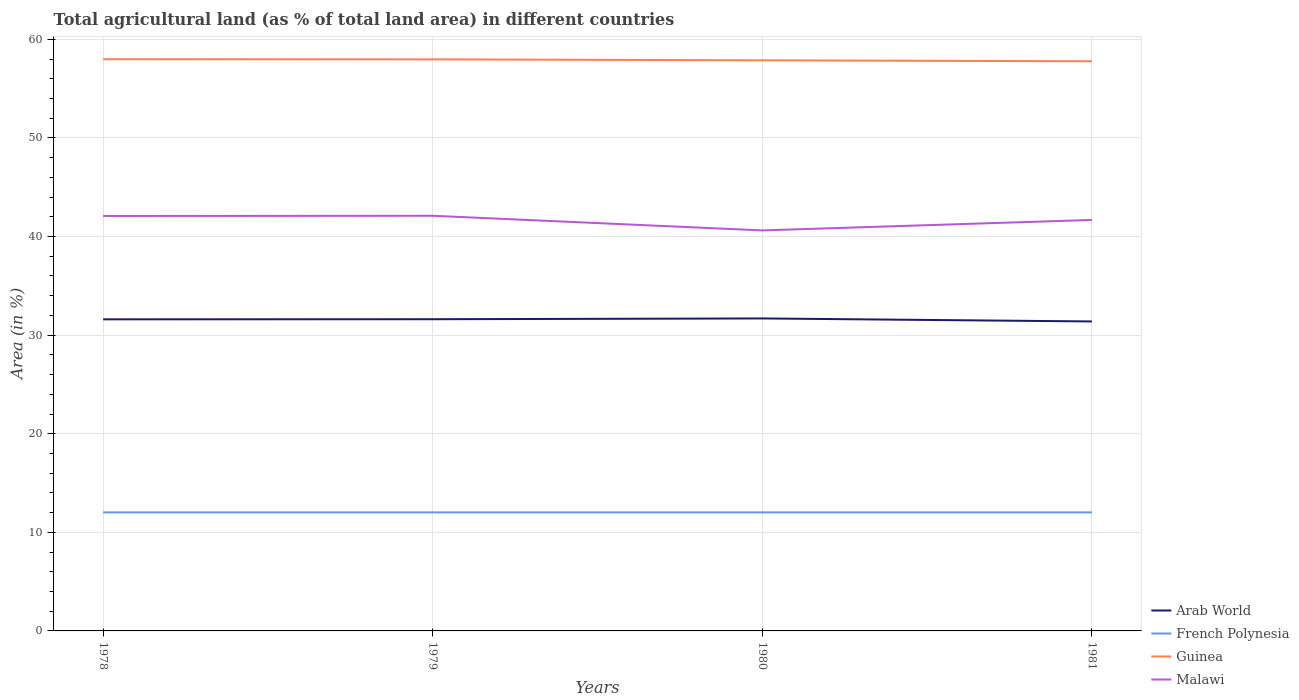How many different coloured lines are there?
Your answer should be compact. 4. Does the line corresponding to Arab World intersect with the line corresponding to French Polynesia?
Provide a short and direct response. No. Across all years, what is the maximum percentage of agricultural land in French Polynesia?
Ensure brevity in your answer.  12.02. What is the total percentage of agricultural land in Guinea in the graph?
Make the answer very short. 0.2. What is the difference between the highest and the second highest percentage of agricultural land in Arab World?
Provide a succinct answer. 0.31. What is the difference between the highest and the lowest percentage of agricultural land in French Polynesia?
Your response must be concise. 0. How many lines are there?
Make the answer very short. 4. How many years are there in the graph?
Your answer should be very brief. 4. Does the graph contain any zero values?
Give a very brief answer. No. Does the graph contain grids?
Offer a very short reply. Yes. How many legend labels are there?
Give a very brief answer. 4. What is the title of the graph?
Offer a very short reply. Total agricultural land (as % of total land area) in different countries. What is the label or title of the X-axis?
Give a very brief answer. Years. What is the label or title of the Y-axis?
Ensure brevity in your answer.  Area (in %). What is the Area (in %) in Arab World in 1978?
Offer a terse response. 31.6. What is the Area (in %) of French Polynesia in 1978?
Offer a terse response. 12.02. What is the Area (in %) of Guinea in 1978?
Offer a terse response. 57.98. What is the Area (in %) of Malawi in 1978?
Provide a succinct answer. 42.09. What is the Area (in %) in Arab World in 1979?
Give a very brief answer. 31.62. What is the Area (in %) of French Polynesia in 1979?
Provide a succinct answer. 12.02. What is the Area (in %) in Guinea in 1979?
Keep it short and to the point. 57.97. What is the Area (in %) in Malawi in 1979?
Keep it short and to the point. 42.11. What is the Area (in %) of Arab World in 1980?
Ensure brevity in your answer.  31.69. What is the Area (in %) of French Polynesia in 1980?
Offer a terse response. 12.02. What is the Area (in %) of Guinea in 1980?
Your answer should be very brief. 57.87. What is the Area (in %) in Malawi in 1980?
Your answer should be compact. 40.62. What is the Area (in %) in Arab World in 1981?
Make the answer very short. 31.39. What is the Area (in %) of French Polynesia in 1981?
Your answer should be compact. 12.02. What is the Area (in %) in Guinea in 1981?
Your answer should be compact. 57.78. What is the Area (in %) in Malawi in 1981?
Your answer should be very brief. 41.68. Across all years, what is the maximum Area (in %) of Arab World?
Your answer should be compact. 31.69. Across all years, what is the maximum Area (in %) of French Polynesia?
Your answer should be compact. 12.02. Across all years, what is the maximum Area (in %) of Guinea?
Provide a short and direct response. 57.98. Across all years, what is the maximum Area (in %) in Malawi?
Your answer should be very brief. 42.11. Across all years, what is the minimum Area (in %) in Arab World?
Offer a terse response. 31.39. Across all years, what is the minimum Area (in %) in French Polynesia?
Give a very brief answer. 12.02. Across all years, what is the minimum Area (in %) in Guinea?
Keep it short and to the point. 57.78. Across all years, what is the minimum Area (in %) in Malawi?
Your answer should be very brief. 40.62. What is the total Area (in %) in Arab World in the graph?
Offer a very short reply. 126.3. What is the total Area (in %) in French Polynesia in the graph?
Provide a succinct answer. 48.09. What is the total Area (in %) in Guinea in the graph?
Your answer should be very brief. 231.61. What is the total Area (in %) of Malawi in the graph?
Provide a succinct answer. 166.5. What is the difference between the Area (in %) of Arab World in 1978 and that in 1979?
Your answer should be compact. -0.01. What is the difference between the Area (in %) in Guinea in 1978 and that in 1979?
Give a very brief answer. 0.01. What is the difference between the Area (in %) of Malawi in 1978 and that in 1979?
Give a very brief answer. -0.02. What is the difference between the Area (in %) of Arab World in 1978 and that in 1980?
Ensure brevity in your answer.  -0.09. What is the difference between the Area (in %) in French Polynesia in 1978 and that in 1980?
Give a very brief answer. 0. What is the difference between the Area (in %) in Guinea in 1978 and that in 1980?
Give a very brief answer. 0.11. What is the difference between the Area (in %) in Malawi in 1978 and that in 1980?
Ensure brevity in your answer.  1.46. What is the difference between the Area (in %) in Arab World in 1978 and that in 1981?
Your response must be concise. 0.22. What is the difference between the Area (in %) in Guinea in 1978 and that in 1981?
Provide a succinct answer. 0.21. What is the difference between the Area (in %) of Malawi in 1978 and that in 1981?
Make the answer very short. 0.4. What is the difference between the Area (in %) of Arab World in 1979 and that in 1980?
Your answer should be compact. -0.08. What is the difference between the Area (in %) in French Polynesia in 1979 and that in 1980?
Provide a short and direct response. 0. What is the difference between the Area (in %) of Guinea in 1979 and that in 1980?
Ensure brevity in your answer.  0.1. What is the difference between the Area (in %) of Malawi in 1979 and that in 1980?
Your response must be concise. 1.48. What is the difference between the Area (in %) in Arab World in 1979 and that in 1981?
Your answer should be very brief. 0.23. What is the difference between the Area (in %) in French Polynesia in 1979 and that in 1981?
Give a very brief answer. 0. What is the difference between the Area (in %) in Guinea in 1979 and that in 1981?
Provide a short and direct response. 0.2. What is the difference between the Area (in %) in Malawi in 1979 and that in 1981?
Offer a very short reply. 0.42. What is the difference between the Area (in %) in Arab World in 1980 and that in 1981?
Your response must be concise. 0.31. What is the difference between the Area (in %) of Guinea in 1980 and that in 1981?
Keep it short and to the point. 0.1. What is the difference between the Area (in %) of Malawi in 1980 and that in 1981?
Offer a terse response. -1.06. What is the difference between the Area (in %) of Arab World in 1978 and the Area (in %) of French Polynesia in 1979?
Your answer should be very brief. 19.58. What is the difference between the Area (in %) in Arab World in 1978 and the Area (in %) in Guinea in 1979?
Your response must be concise. -26.37. What is the difference between the Area (in %) of Arab World in 1978 and the Area (in %) of Malawi in 1979?
Provide a succinct answer. -10.5. What is the difference between the Area (in %) of French Polynesia in 1978 and the Area (in %) of Guinea in 1979?
Your response must be concise. -45.95. What is the difference between the Area (in %) in French Polynesia in 1978 and the Area (in %) in Malawi in 1979?
Keep it short and to the point. -30.09. What is the difference between the Area (in %) in Guinea in 1978 and the Area (in %) in Malawi in 1979?
Offer a very short reply. 15.88. What is the difference between the Area (in %) in Arab World in 1978 and the Area (in %) in French Polynesia in 1980?
Your answer should be very brief. 19.58. What is the difference between the Area (in %) of Arab World in 1978 and the Area (in %) of Guinea in 1980?
Your answer should be compact. -26.27. What is the difference between the Area (in %) of Arab World in 1978 and the Area (in %) of Malawi in 1980?
Offer a terse response. -9.02. What is the difference between the Area (in %) in French Polynesia in 1978 and the Area (in %) in Guinea in 1980?
Your response must be concise. -45.85. What is the difference between the Area (in %) in French Polynesia in 1978 and the Area (in %) in Malawi in 1980?
Keep it short and to the point. -28.6. What is the difference between the Area (in %) of Guinea in 1978 and the Area (in %) of Malawi in 1980?
Give a very brief answer. 17.36. What is the difference between the Area (in %) in Arab World in 1978 and the Area (in %) in French Polynesia in 1981?
Provide a short and direct response. 19.58. What is the difference between the Area (in %) in Arab World in 1978 and the Area (in %) in Guinea in 1981?
Provide a succinct answer. -26.17. What is the difference between the Area (in %) of Arab World in 1978 and the Area (in %) of Malawi in 1981?
Provide a short and direct response. -10.08. What is the difference between the Area (in %) in French Polynesia in 1978 and the Area (in %) in Guinea in 1981?
Provide a short and direct response. -45.76. What is the difference between the Area (in %) in French Polynesia in 1978 and the Area (in %) in Malawi in 1981?
Your answer should be compact. -29.66. What is the difference between the Area (in %) in Guinea in 1978 and the Area (in %) in Malawi in 1981?
Your response must be concise. 16.3. What is the difference between the Area (in %) of Arab World in 1979 and the Area (in %) of French Polynesia in 1980?
Your answer should be compact. 19.59. What is the difference between the Area (in %) of Arab World in 1979 and the Area (in %) of Guinea in 1980?
Offer a terse response. -26.26. What is the difference between the Area (in %) of Arab World in 1979 and the Area (in %) of Malawi in 1980?
Make the answer very short. -9.01. What is the difference between the Area (in %) in French Polynesia in 1979 and the Area (in %) in Guinea in 1980?
Give a very brief answer. -45.85. What is the difference between the Area (in %) in French Polynesia in 1979 and the Area (in %) in Malawi in 1980?
Offer a terse response. -28.6. What is the difference between the Area (in %) of Guinea in 1979 and the Area (in %) of Malawi in 1980?
Give a very brief answer. 17.35. What is the difference between the Area (in %) in Arab World in 1979 and the Area (in %) in French Polynesia in 1981?
Your response must be concise. 19.59. What is the difference between the Area (in %) of Arab World in 1979 and the Area (in %) of Guinea in 1981?
Ensure brevity in your answer.  -26.16. What is the difference between the Area (in %) in Arab World in 1979 and the Area (in %) in Malawi in 1981?
Keep it short and to the point. -10.07. What is the difference between the Area (in %) of French Polynesia in 1979 and the Area (in %) of Guinea in 1981?
Keep it short and to the point. -45.76. What is the difference between the Area (in %) in French Polynesia in 1979 and the Area (in %) in Malawi in 1981?
Your response must be concise. -29.66. What is the difference between the Area (in %) in Guinea in 1979 and the Area (in %) in Malawi in 1981?
Provide a succinct answer. 16.29. What is the difference between the Area (in %) in Arab World in 1980 and the Area (in %) in French Polynesia in 1981?
Your response must be concise. 19.67. What is the difference between the Area (in %) of Arab World in 1980 and the Area (in %) of Guinea in 1981?
Your answer should be compact. -26.08. What is the difference between the Area (in %) of Arab World in 1980 and the Area (in %) of Malawi in 1981?
Keep it short and to the point. -9.99. What is the difference between the Area (in %) in French Polynesia in 1980 and the Area (in %) in Guinea in 1981?
Offer a very short reply. -45.76. What is the difference between the Area (in %) of French Polynesia in 1980 and the Area (in %) of Malawi in 1981?
Your response must be concise. -29.66. What is the difference between the Area (in %) of Guinea in 1980 and the Area (in %) of Malawi in 1981?
Offer a very short reply. 16.19. What is the average Area (in %) of Arab World per year?
Ensure brevity in your answer.  31.58. What is the average Area (in %) of French Polynesia per year?
Keep it short and to the point. 12.02. What is the average Area (in %) in Guinea per year?
Your answer should be compact. 57.9. What is the average Area (in %) in Malawi per year?
Provide a short and direct response. 41.63. In the year 1978, what is the difference between the Area (in %) of Arab World and Area (in %) of French Polynesia?
Your answer should be compact. 19.58. In the year 1978, what is the difference between the Area (in %) of Arab World and Area (in %) of Guinea?
Provide a short and direct response. -26.38. In the year 1978, what is the difference between the Area (in %) of Arab World and Area (in %) of Malawi?
Provide a short and direct response. -10.48. In the year 1978, what is the difference between the Area (in %) in French Polynesia and Area (in %) in Guinea?
Ensure brevity in your answer.  -45.96. In the year 1978, what is the difference between the Area (in %) of French Polynesia and Area (in %) of Malawi?
Provide a short and direct response. -30.07. In the year 1978, what is the difference between the Area (in %) of Guinea and Area (in %) of Malawi?
Offer a very short reply. 15.9. In the year 1979, what is the difference between the Area (in %) of Arab World and Area (in %) of French Polynesia?
Keep it short and to the point. 19.59. In the year 1979, what is the difference between the Area (in %) in Arab World and Area (in %) in Guinea?
Your answer should be very brief. -26.36. In the year 1979, what is the difference between the Area (in %) of Arab World and Area (in %) of Malawi?
Your answer should be compact. -10.49. In the year 1979, what is the difference between the Area (in %) in French Polynesia and Area (in %) in Guinea?
Make the answer very short. -45.95. In the year 1979, what is the difference between the Area (in %) of French Polynesia and Area (in %) of Malawi?
Provide a succinct answer. -30.09. In the year 1979, what is the difference between the Area (in %) in Guinea and Area (in %) in Malawi?
Offer a terse response. 15.86. In the year 1980, what is the difference between the Area (in %) in Arab World and Area (in %) in French Polynesia?
Offer a very short reply. 19.67. In the year 1980, what is the difference between the Area (in %) in Arab World and Area (in %) in Guinea?
Ensure brevity in your answer.  -26.18. In the year 1980, what is the difference between the Area (in %) in Arab World and Area (in %) in Malawi?
Your response must be concise. -8.93. In the year 1980, what is the difference between the Area (in %) in French Polynesia and Area (in %) in Guinea?
Give a very brief answer. -45.85. In the year 1980, what is the difference between the Area (in %) of French Polynesia and Area (in %) of Malawi?
Your answer should be compact. -28.6. In the year 1980, what is the difference between the Area (in %) in Guinea and Area (in %) in Malawi?
Your answer should be very brief. 17.25. In the year 1981, what is the difference between the Area (in %) of Arab World and Area (in %) of French Polynesia?
Your response must be concise. 19.37. In the year 1981, what is the difference between the Area (in %) in Arab World and Area (in %) in Guinea?
Your answer should be very brief. -26.39. In the year 1981, what is the difference between the Area (in %) in Arab World and Area (in %) in Malawi?
Your answer should be compact. -10.3. In the year 1981, what is the difference between the Area (in %) of French Polynesia and Area (in %) of Guinea?
Your answer should be compact. -45.76. In the year 1981, what is the difference between the Area (in %) in French Polynesia and Area (in %) in Malawi?
Make the answer very short. -29.66. In the year 1981, what is the difference between the Area (in %) in Guinea and Area (in %) in Malawi?
Your answer should be very brief. 16.09. What is the ratio of the Area (in %) of Guinea in 1978 to that in 1979?
Give a very brief answer. 1. What is the ratio of the Area (in %) of Malawi in 1978 to that in 1979?
Make the answer very short. 1. What is the ratio of the Area (in %) in Arab World in 1978 to that in 1980?
Offer a very short reply. 1. What is the ratio of the Area (in %) of Guinea in 1978 to that in 1980?
Provide a short and direct response. 1. What is the ratio of the Area (in %) of Malawi in 1978 to that in 1980?
Your response must be concise. 1.04. What is the ratio of the Area (in %) in Arab World in 1978 to that in 1981?
Make the answer very short. 1.01. What is the ratio of the Area (in %) of French Polynesia in 1978 to that in 1981?
Your response must be concise. 1. What is the ratio of the Area (in %) in Guinea in 1978 to that in 1981?
Keep it short and to the point. 1. What is the ratio of the Area (in %) in Malawi in 1978 to that in 1981?
Ensure brevity in your answer.  1.01. What is the ratio of the Area (in %) in Arab World in 1979 to that in 1980?
Give a very brief answer. 1. What is the ratio of the Area (in %) in French Polynesia in 1979 to that in 1980?
Your response must be concise. 1. What is the ratio of the Area (in %) of Guinea in 1979 to that in 1980?
Give a very brief answer. 1. What is the ratio of the Area (in %) in Malawi in 1979 to that in 1980?
Offer a terse response. 1.04. What is the ratio of the Area (in %) in French Polynesia in 1979 to that in 1981?
Your answer should be very brief. 1. What is the ratio of the Area (in %) in Malawi in 1979 to that in 1981?
Provide a short and direct response. 1.01. What is the ratio of the Area (in %) in Arab World in 1980 to that in 1981?
Make the answer very short. 1.01. What is the ratio of the Area (in %) of French Polynesia in 1980 to that in 1981?
Your response must be concise. 1. What is the ratio of the Area (in %) of Malawi in 1980 to that in 1981?
Make the answer very short. 0.97. What is the difference between the highest and the second highest Area (in %) in Arab World?
Provide a short and direct response. 0.08. What is the difference between the highest and the second highest Area (in %) in Guinea?
Provide a succinct answer. 0.01. What is the difference between the highest and the second highest Area (in %) in Malawi?
Ensure brevity in your answer.  0.02. What is the difference between the highest and the lowest Area (in %) in Arab World?
Make the answer very short. 0.31. What is the difference between the highest and the lowest Area (in %) in French Polynesia?
Your response must be concise. 0. What is the difference between the highest and the lowest Area (in %) of Guinea?
Your answer should be very brief. 0.21. What is the difference between the highest and the lowest Area (in %) of Malawi?
Keep it short and to the point. 1.48. 